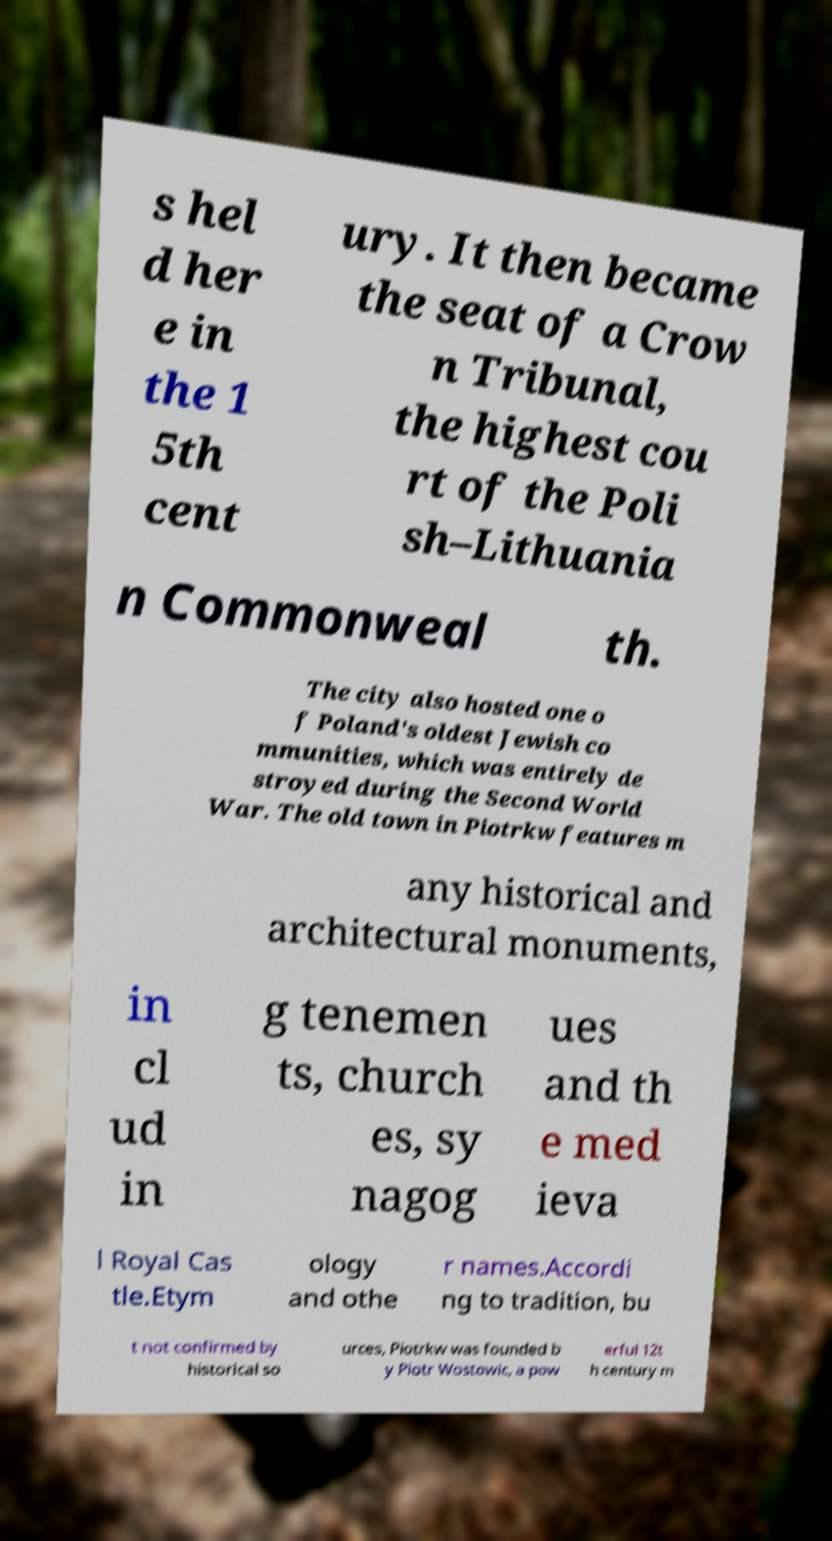Can you read and provide the text displayed in the image?This photo seems to have some interesting text. Can you extract and type it out for me? s hel d her e in the 1 5th cent ury. It then became the seat of a Crow n Tribunal, the highest cou rt of the Poli sh–Lithuania n Commonweal th. The city also hosted one o f Poland's oldest Jewish co mmunities, which was entirely de stroyed during the Second World War. The old town in Piotrkw features m any historical and architectural monuments, in cl ud in g tenemen ts, church es, sy nagog ues and th e med ieva l Royal Cas tle.Etym ology and othe r names.Accordi ng to tradition, bu t not confirmed by historical so urces, Piotrkw was founded b y Piotr Wostowic, a pow erful 12t h century m 